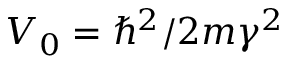Convert formula to latex. <formula><loc_0><loc_0><loc_500><loc_500>V _ { 0 } = \hbar { ^ } { 2 } / 2 m \gamma ^ { 2 }</formula> 